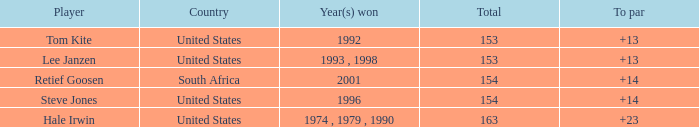What is the greatest to par that is under 153? None. 